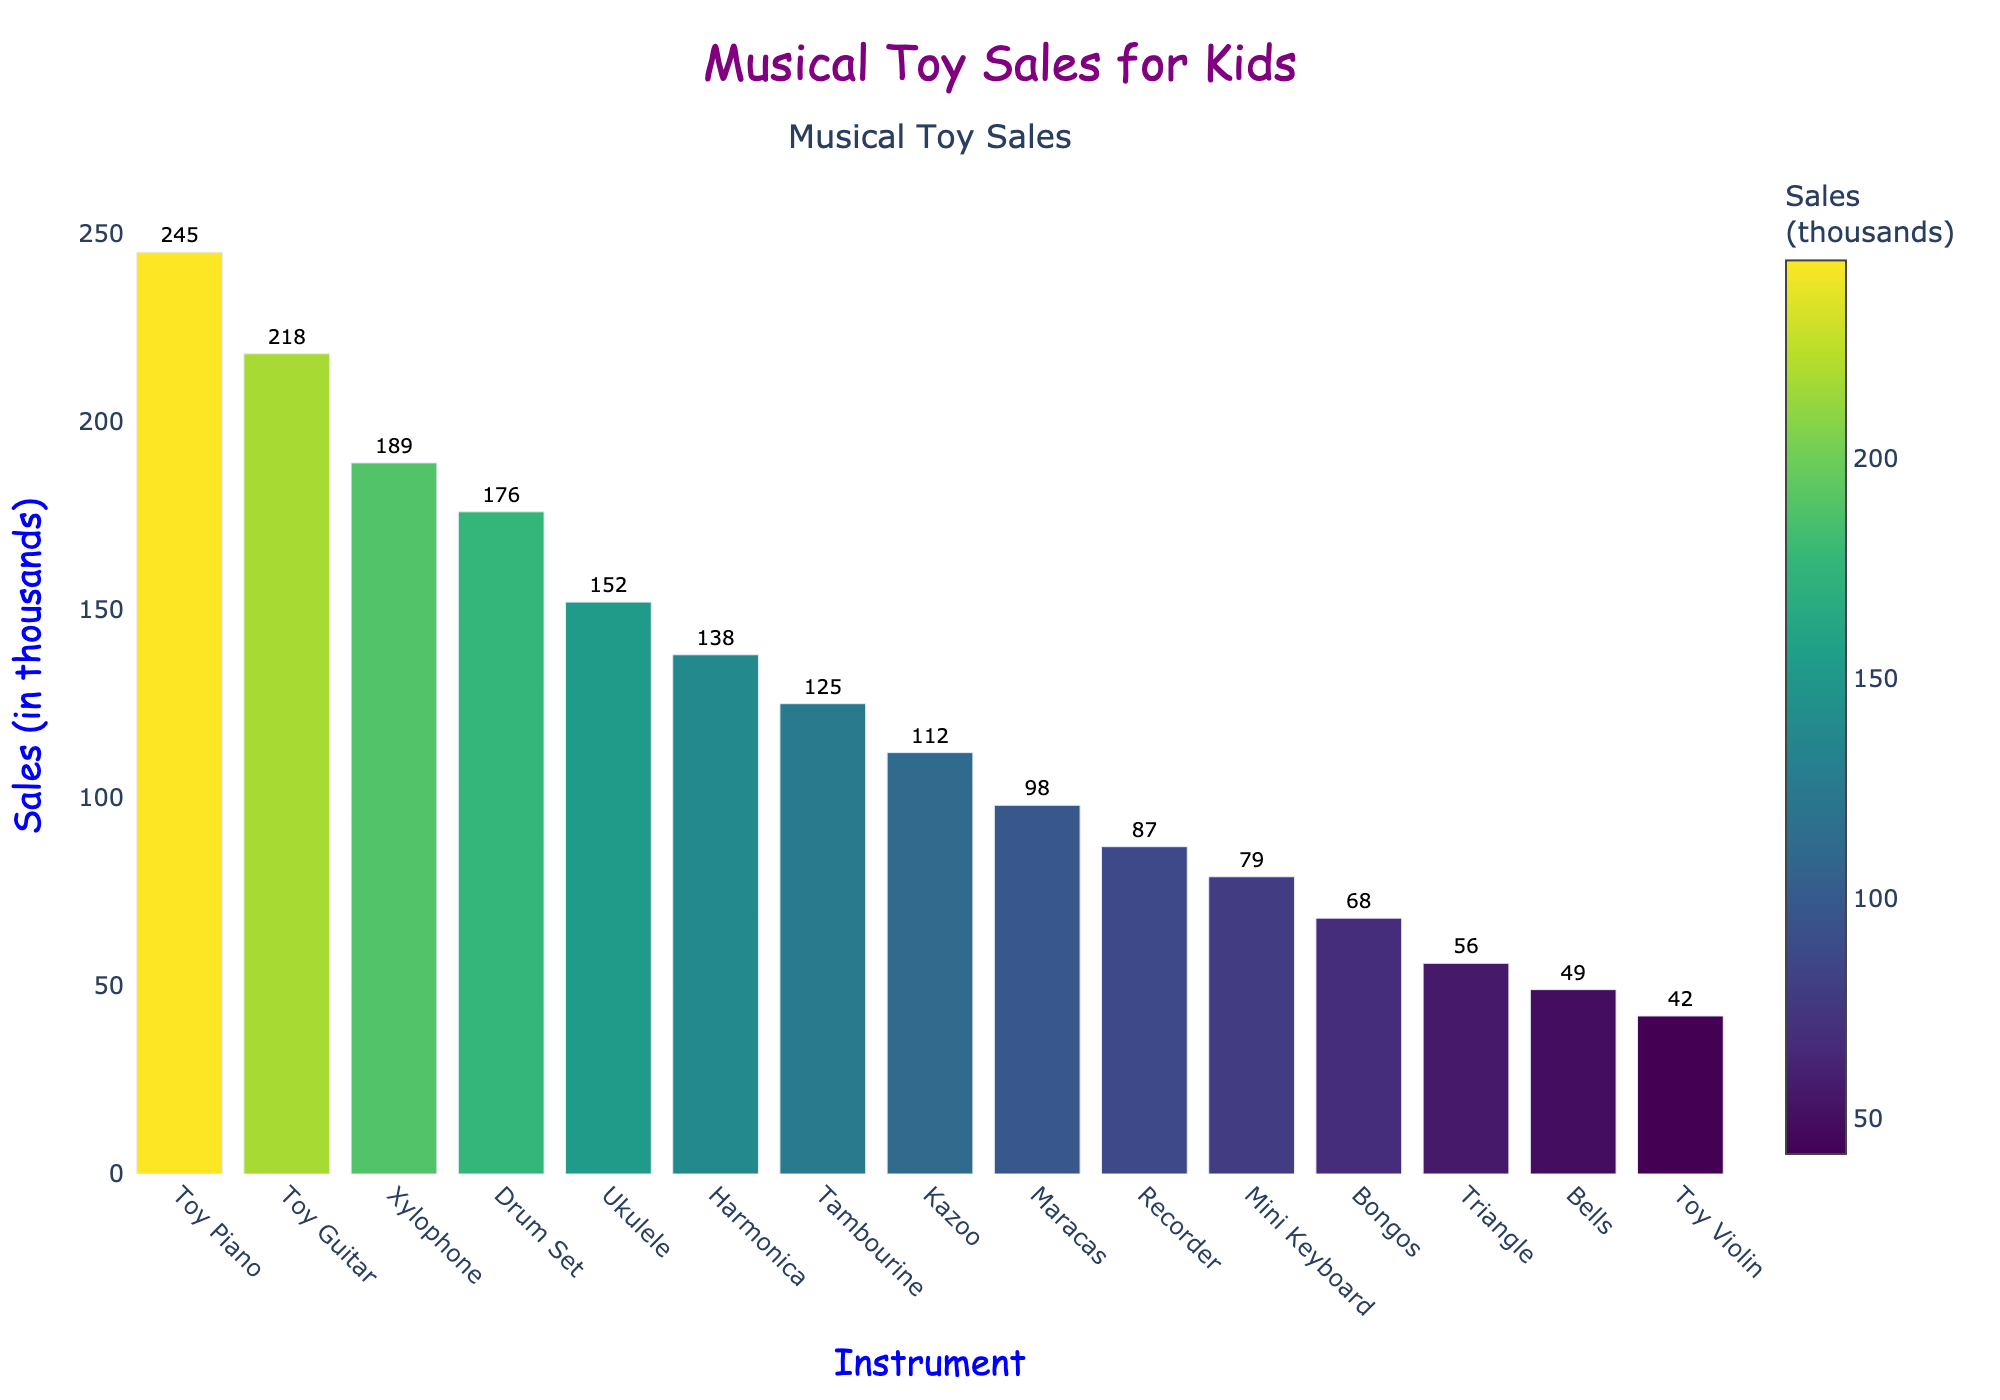Which instrument had the highest sales? Look for the tallest bar in the chart, which represents the highest sales figure. The instrument labeled at the top of this bar is the one with the highest sales.
Answer: Toy Piano Which instrument had the lowest sales? Find the shortest bar in the chart. The instrument labeled at the top of this bar is the one with the lowest sales.
Answer: Toy Violin How much more did the Toy Piano sell than the Recorder? Identify the sales figures for the Toy Piano and the Recorder. Subtract the Recorder's sales from the Toy Piano's sales. That is, 245 (Toy Piano) - 87 (Recorder) = 158
Answer: 158 Which sold more, the Toy Guitar or the Drum Set? Compare the heights of the bars for the Toy Guitar and the Drum Set. The taller bar represents the instrument with higher sales. The Toy Guitar bar is taller than the Drum Set bar.
Answer: Toy Guitar What is the average sales of the top 3 selling instruments? Identify the sales figures of the top 3 instruments: Toy Piano (245), Toy Guitar (218), and Xylophone (189). Compute their average by adding and dividing by 3: (245 + 218 + 189) / 3 = 652 / 3
Answer: 217.33 What is the total sales figure for the Bongos and the Bells combined? Sum the sales figures for both instruments: 68 (Bongos) + 49 (Bells) = 117
Answer: 117 How many instruments sold over 100,000 units? Count the number of bars with values exceeding 100,000 from the y-axis. Instruments exceeding this number are: Toy Piano, Toy Guitar, Xylophone, Drum Set, Ukulele, Harmonica, Tambourine, and Kazoo.
Answer: 8 Is the percentage of sales for the Kazoo higher or lower than that of the Tambourine? Compare the heights of the bars for Kazoo and Tambourine. The Kazoo's bar is shorter than that of the Tambourine, indicating lower sales and thus a lower percentage of total sales.
Answer: Lower Which color on the Viridis color scale represents the highest sales? The visual attribute indicating the highest sales on the bar marked as Toy Piano is the color. On the Viridis scale, this corresponds to the color associated with the highest value.
Answer: Brighter Yellow/Green Between the Ukulele and Mini Keyboard, which instrument had more than double the sales of the other? Compare the sales of each: Ukulele (152) and Mini Keyboard (79). Doubling the Mini Keyboard sales gives 79 * 2 = 158, which is greater than 152 for Ukulele. Therefore, no instrument had more than double the sales of the other.
Answer: Neither 